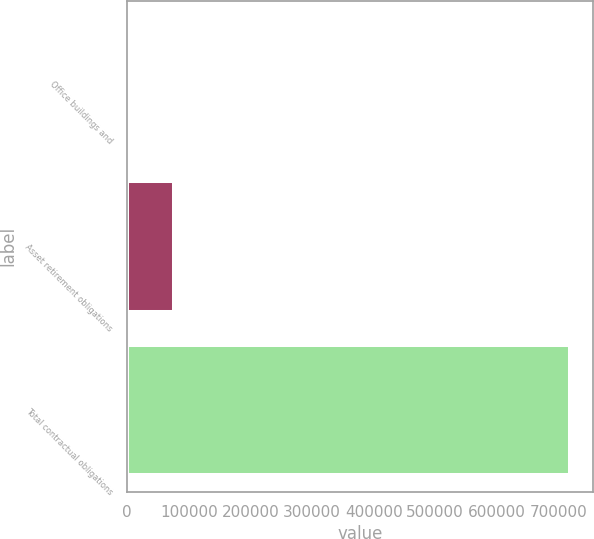<chart> <loc_0><loc_0><loc_500><loc_500><bar_chart><fcel>Office buildings and<fcel>Asset retirement obligations<fcel>Total contractual obligations<nl><fcel>4986<fcel>76429.3<fcel>719419<nl></chart> 